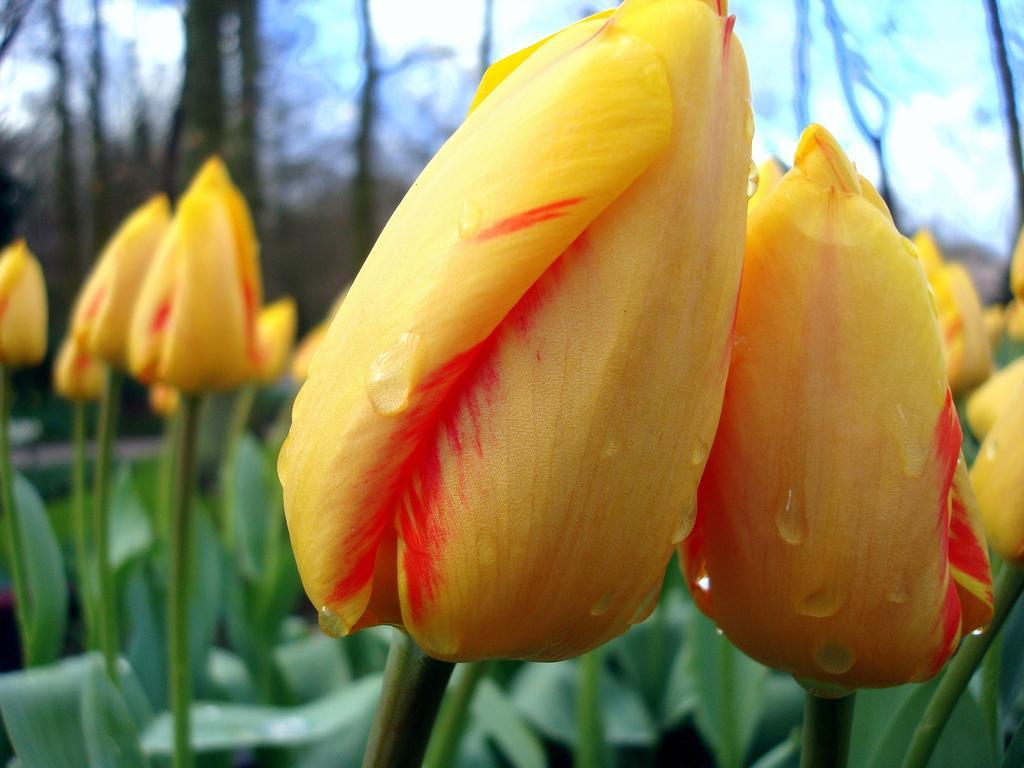Could you give a brief overview of what you see in this image? In this image I can see few flowers in yellow and orange color and I can see few leaves in green color, background the sky is in white color. 